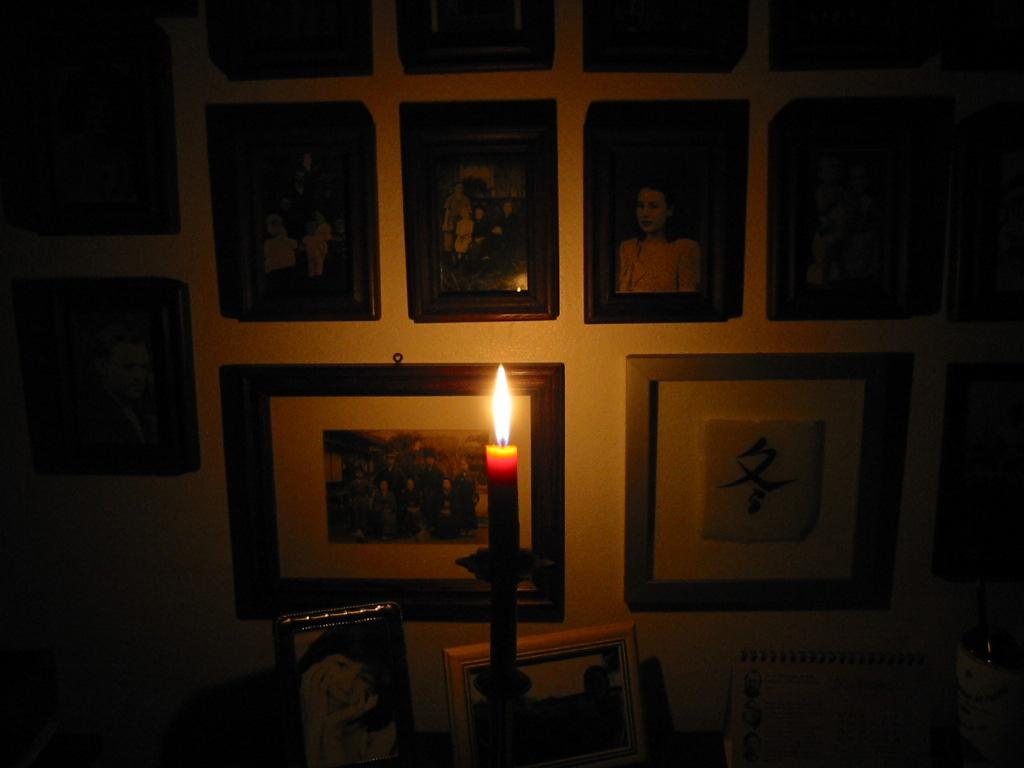What object in the image has a flame? The candle in the image has a flame. What can be found on the wall in the image? There are frames on the wall in the image. What are the frames containing? The frames contain pictures of people wearing clothes. What type of rock is being advertised in the image? There is no rock or advertisement present in the image. What color is the candle in the image? The color of the candle is not mentioned in the provided facts, so it cannot be determined from the image. 